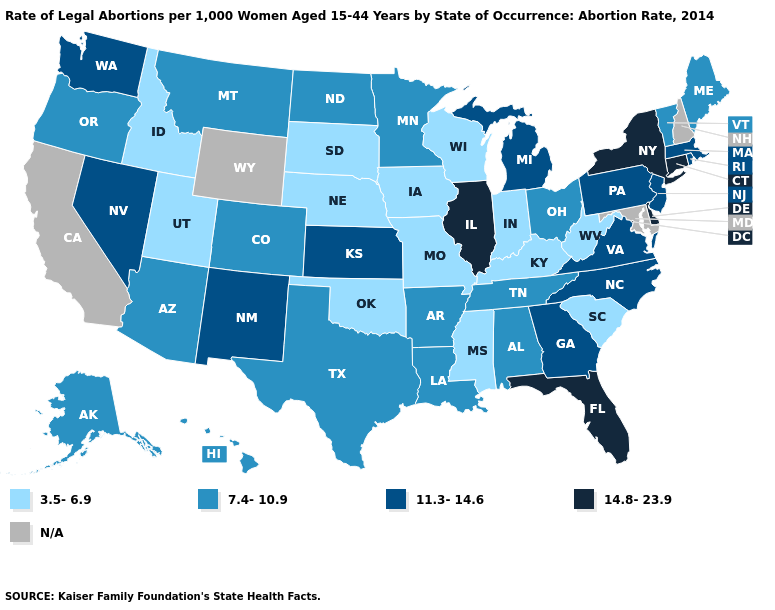Name the states that have a value in the range 3.5-6.9?
Concise answer only. Idaho, Indiana, Iowa, Kentucky, Mississippi, Missouri, Nebraska, Oklahoma, South Carolina, South Dakota, Utah, West Virginia, Wisconsin. What is the lowest value in states that border South Dakota?
Give a very brief answer. 3.5-6.9. What is the value of Minnesota?
Be succinct. 7.4-10.9. What is the value of Maine?
Quick response, please. 7.4-10.9. Name the states that have a value in the range 14.8-23.9?
Short answer required. Connecticut, Delaware, Florida, Illinois, New York. Among the states that border Arkansas , does Mississippi have the lowest value?
Concise answer only. Yes. Is the legend a continuous bar?
Give a very brief answer. No. Name the states that have a value in the range 7.4-10.9?
Be succinct. Alabama, Alaska, Arizona, Arkansas, Colorado, Hawaii, Louisiana, Maine, Minnesota, Montana, North Dakota, Ohio, Oregon, Tennessee, Texas, Vermont. Among the states that border Connecticut , does New York have the lowest value?
Give a very brief answer. No. What is the value of Pennsylvania?
Give a very brief answer. 11.3-14.6. What is the highest value in the MidWest ?
Short answer required. 14.8-23.9. What is the value of Michigan?
Answer briefly. 11.3-14.6. What is the value of Iowa?
Answer briefly. 3.5-6.9. Does Nebraska have the highest value in the MidWest?
Give a very brief answer. No. Does South Carolina have the lowest value in the South?
Answer briefly. Yes. 